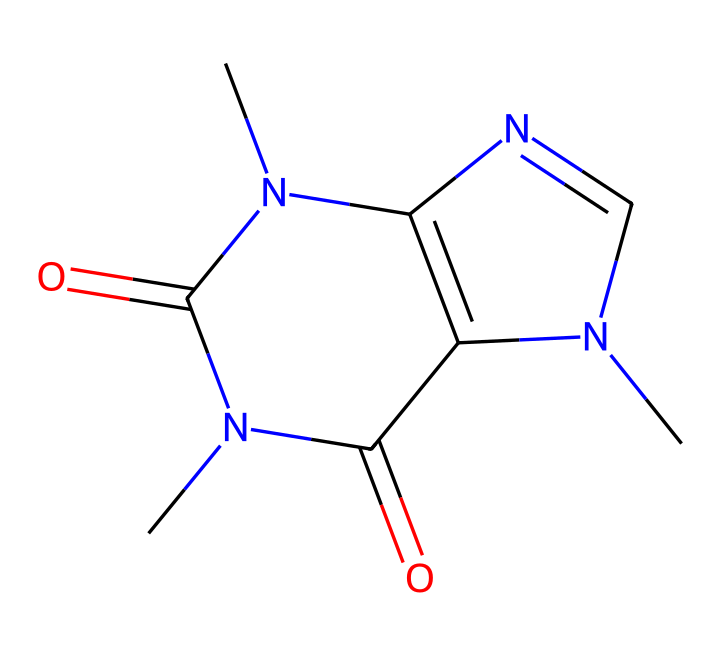What is the molecular formula of caffeine? By analyzing the structure represented in the SMILES notation, we can count the number of each type of atom present. The structure has 8 carbon (C) atoms, 10 hydrogen (H) atoms, 4 nitrogen (N) atoms, and 2 oxygen (O) atoms. Thus, combining these gives us the molecular formula C8H10N4O2.
Answer: C8H10N4O2 How many rings are present in the caffeine structure? The caffeine structure contains two interconnected rings, which can be identified by looking at the closed loops formed by the carbon and nitrogen atoms in the SMILES sequence.
Answer: 2 What type of functional groups are present in caffeine? By examining the structure and identifying the groups attached to the carbon atoms, we can find carbonyl (C=O) and amine (-NH) functional groups. These influence the chemical properties of caffeine significantly.
Answer: carbonyl and amine What is the primary nitrogen configuration in caffeine? The structure indicates the presence of nitrogen atoms that are part of the ring system. In this case, we can see that they are part of imidazole and pyrimidine-like arrangements which are characteristic of many alkaloids.
Answer: alkaloidal rings Which part of the caffeine structure contributes to its stimulant properties? The presence of nitrogen atoms, particularly within the structure's condensed rings, contributes to the pharmacological properties of caffeine, primarily its ability to act as a stimulant by blocking adenosine receptors in the brain.
Answer: nitrogen rings 